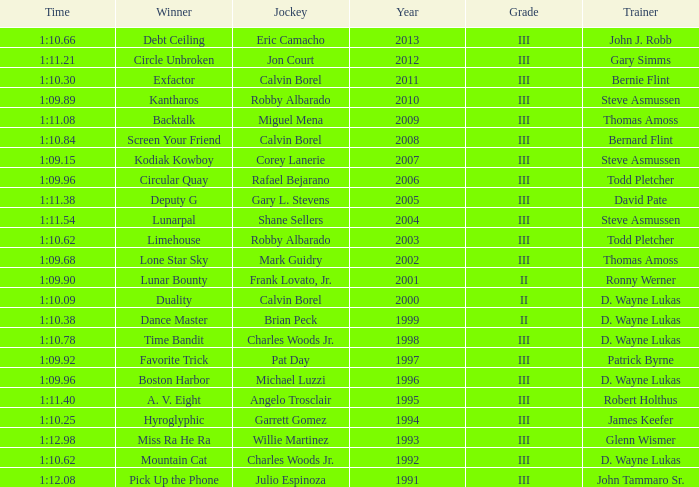What was the time for Screen Your Friend? 1:10.84. 